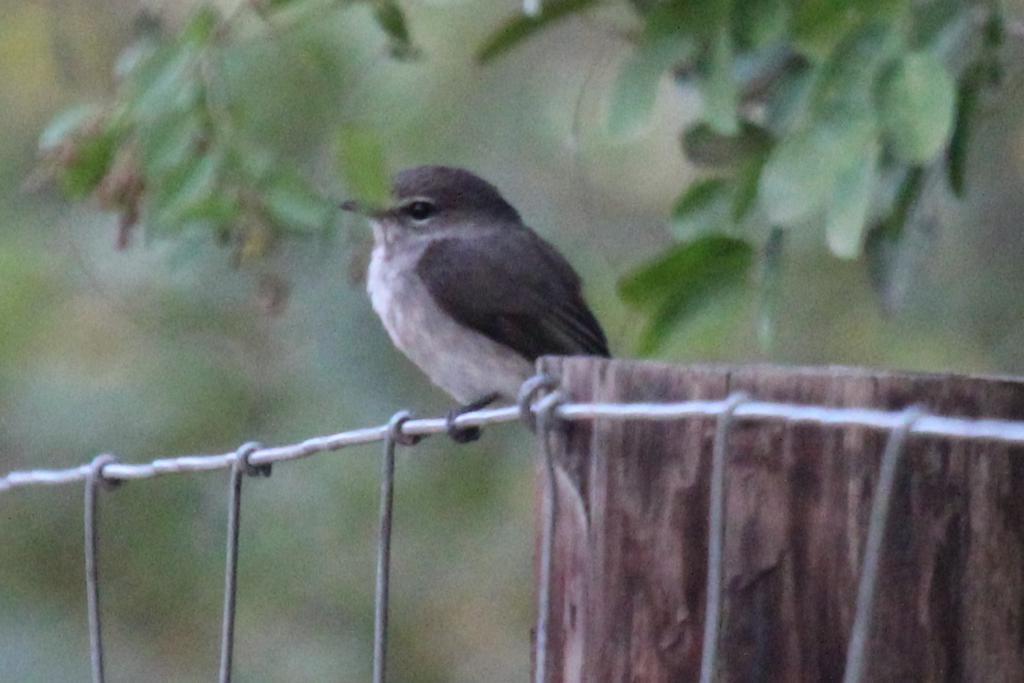In one or two sentences, can you explain what this image depicts? There is a bird sitting on a steel rod. Near to that there is a wooden log. In the back there are leaves and it is blurred. On the steel rod there are some other steel rods connected. 